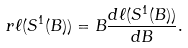Convert formula to latex. <formula><loc_0><loc_0><loc_500><loc_500>r \ell ( S ^ { 1 } ( B ) ) = B \frac { d \ell ( S ^ { 1 } ( B ) ) } { d B } .</formula> 